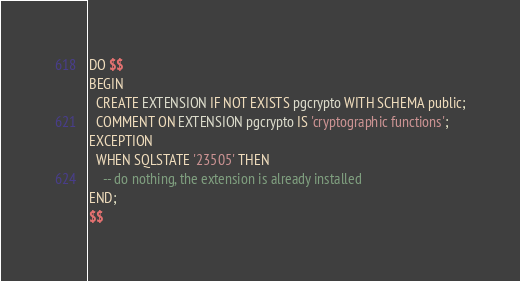Convert code to text. <code><loc_0><loc_0><loc_500><loc_500><_SQL_>DO $$
BEGIN
  CREATE EXTENSION IF NOT EXISTS pgcrypto WITH SCHEMA public;
  COMMENT ON EXTENSION pgcrypto IS 'cryptographic functions';
EXCEPTION
  WHEN SQLSTATE '23505' THEN 
	-- do nothing, the extension is already installed
END; 
$$
</code> 